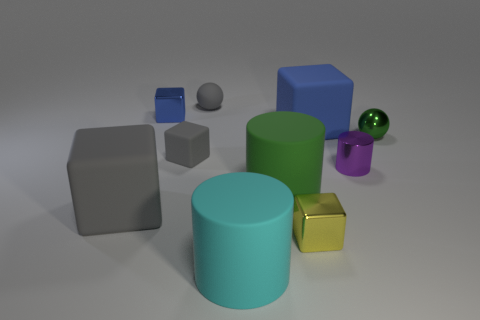Subtract all blue blocks. How many blocks are left? 3 Subtract 1 cylinders. How many cylinders are left? 2 Subtract all blue balls. How many gray cubes are left? 2 Subtract all gray cubes. How many cubes are left? 3 Subtract all red cylinders. Subtract all blue spheres. How many cylinders are left? 3 Subtract all spheres. How many objects are left? 8 Subtract all big brown matte objects. Subtract all big gray things. How many objects are left? 9 Add 3 matte objects. How many matte objects are left? 9 Add 2 big blocks. How many big blocks exist? 4 Subtract 2 blue blocks. How many objects are left? 8 